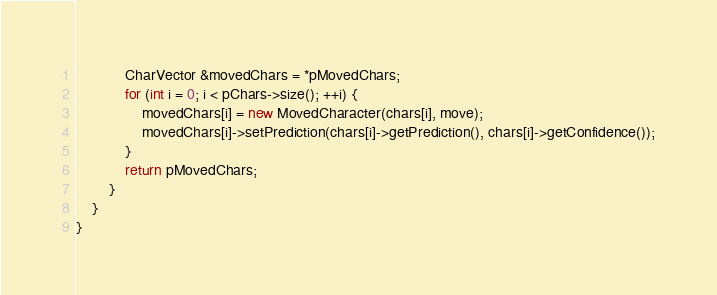<code> <loc_0><loc_0><loc_500><loc_500><_C++_>            CharVector &movedChars = *pMovedChars;
            for (int i = 0; i < pChars->size(); ++i) {
                movedChars[i] = new MovedCharacter(chars[i], move);
                movedChars[i]->setPrediction(chars[i]->getPrediction(), chars[i]->getConfidence());
            }
            return pMovedChars;
        }
    }
}</code> 